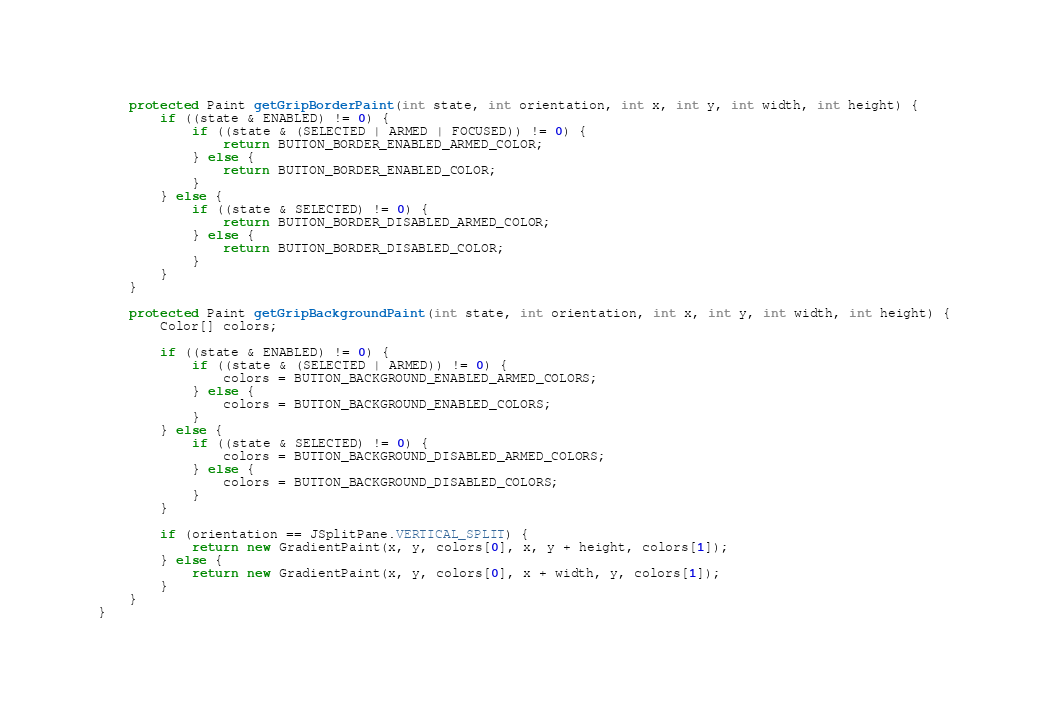<code> <loc_0><loc_0><loc_500><loc_500><_Java_>
	protected Paint getGripBorderPaint(int state, int orientation, int x, int y, int width, int height) {
		if ((state & ENABLED) != 0) {
			if ((state & (SELECTED | ARMED | FOCUSED)) != 0) {
				return BUTTON_BORDER_ENABLED_ARMED_COLOR;
			} else {
				return BUTTON_BORDER_ENABLED_COLOR;
			}
		} else {
			if ((state & SELECTED) != 0) {
				return BUTTON_BORDER_DISABLED_ARMED_COLOR;
			} else {
				return BUTTON_BORDER_DISABLED_COLOR;
			}
		}
	}

	protected Paint getGripBackgroundPaint(int state, int orientation, int x, int y, int width, int height) {
		Color[] colors;
		
		if ((state & ENABLED) != 0) {
			if ((state & (SELECTED | ARMED)) != 0) {
				colors = BUTTON_BACKGROUND_ENABLED_ARMED_COLORS;
			} else {
				colors = BUTTON_BACKGROUND_ENABLED_COLORS;
			}
		} else {
			if ((state & SELECTED) != 0) {
				colors = BUTTON_BACKGROUND_DISABLED_ARMED_COLORS;
			} else {
				colors = BUTTON_BACKGROUND_DISABLED_COLORS;
			}
		}
		
		if (orientation == JSplitPane.VERTICAL_SPLIT) {
			return new GradientPaint(x, y, colors[0], x, y + height, colors[1]);
		} else {
			return new GradientPaint(x, y, colors[0], x + width, y, colors[1]);
		}
	}
}
</code> 